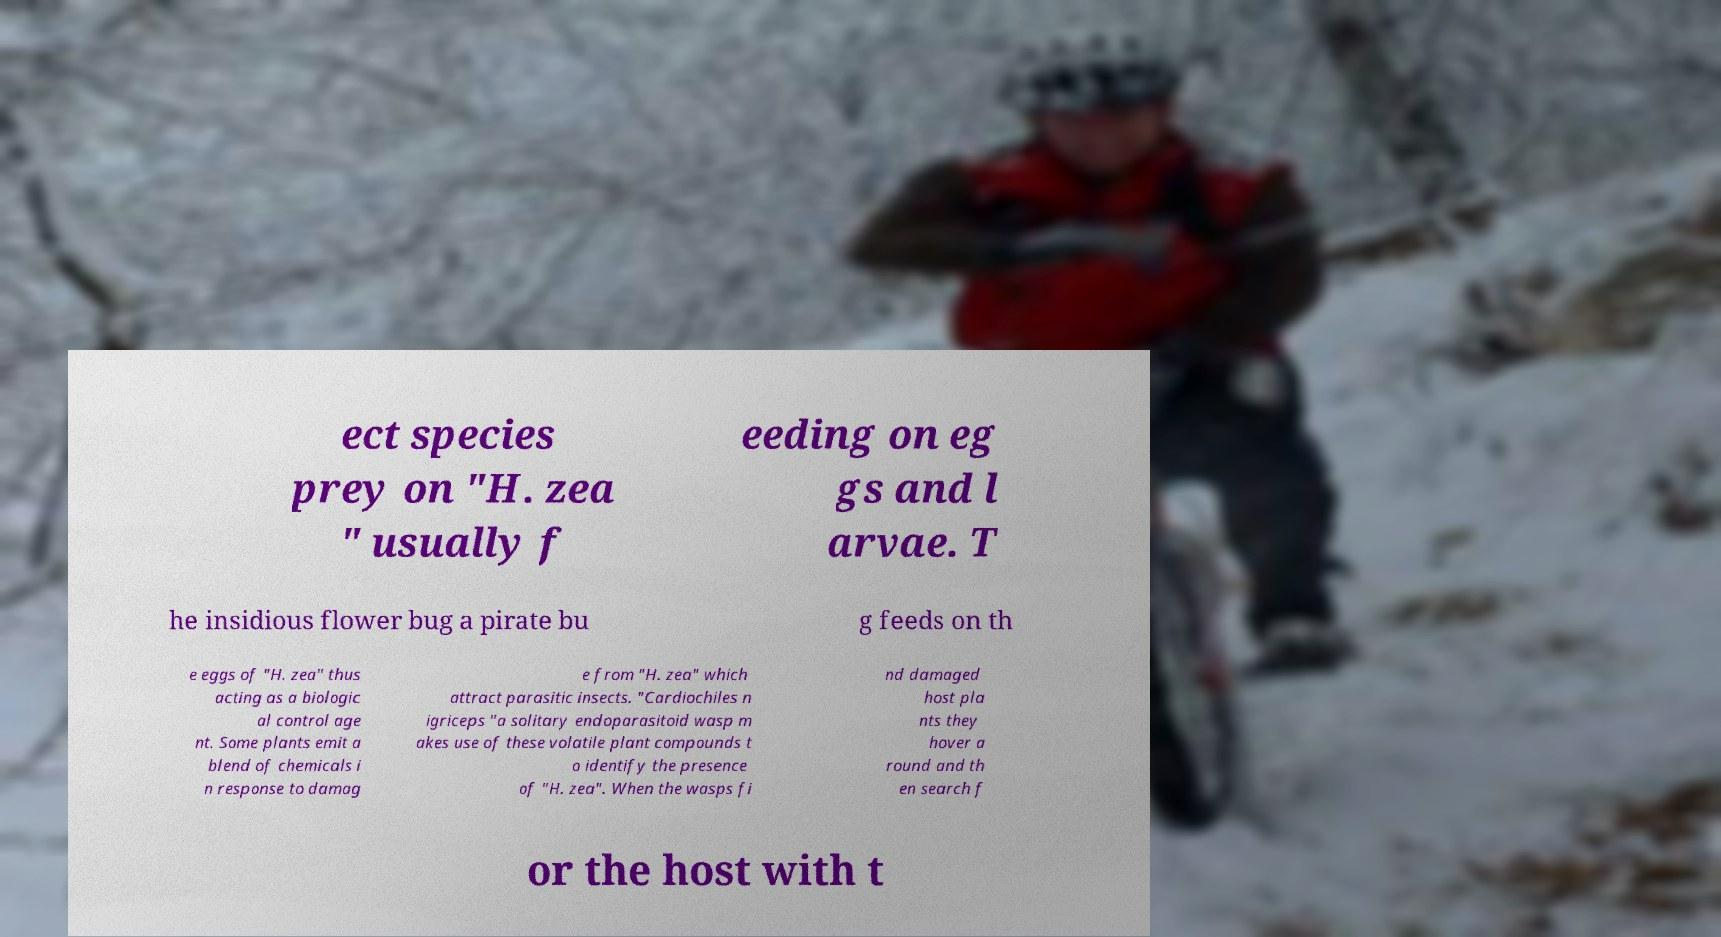Please identify and transcribe the text found in this image. ect species prey on "H. zea " usually f eeding on eg gs and l arvae. T he insidious flower bug a pirate bu g feeds on th e eggs of "H. zea" thus acting as a biologic al control age nt. Some plants emit a blend of chemicals i n response to damag e from "H. zea" which attract parasitic insects. "Cardiochiles n igriceps "a solitary endoparasitoid wasp m akes use of these volatile plant compounds t o identify the presence of "H. zea". When the wasps fi nd damaged host pla nts they hover a round and th en search f or the host with t 